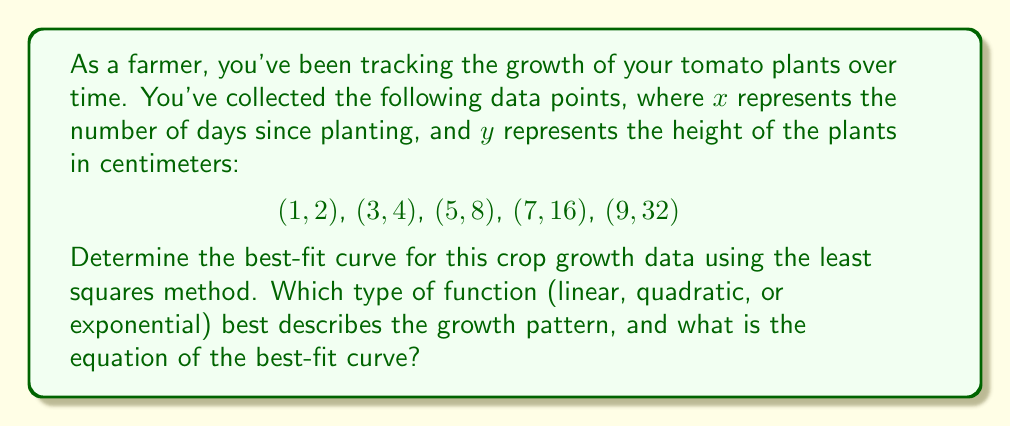Can you solve this math problem? To determine the best-fit curve, we'll consider three types of functions: linear, quadratic, and exponential. We'll use the least squares method to find the best fit for each type and compare their sum of squared residuals (SSR).

1. Linear function: $y = ax + b$
   Using the least squares method, we get:
   $a = 3.8$, $b = -4.2$
   Equation: $y = 3.8x - 4.2$
   SSR = 226.04

2. Quadratic function: $y = ax^2 + bx + c$
   Using the least squares method, we get:
   $a = 0.3786$, $b = -0.0714$, $c = 1.6929$
   Equation: $y = 0.3786x^2 - 0.0714x + 1.6929$
   SSR = 6.7143

3. Exponential function: $y = ae^{bx}$
   Taking the natural logarithm of both sides: $\ln(y) = \ln(a) + bx$
   Using the least squares method on the transformed data, we get:
   $\ln(a) = 0.6555$, $b = 0.3466$
   Equation: $y = 1.9261e^{0.3466x}$
   SSR = 0.7162

Comparing the SSR values:
Linear: 226.04
Quadratic: 6.7143
Exponential: 0.7162

The exponential function has the lowest SSR, indicating it provides the best fit for the crop growth data.
Answer: Exponential function: $y = 1.9261e^{0.3466x}$ 